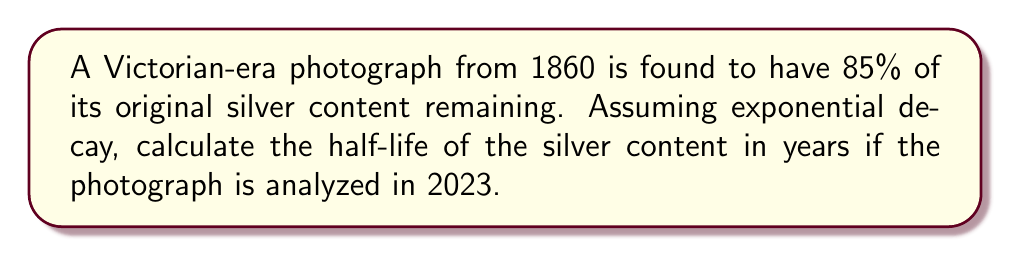Show me your answer to this math problem. Let's approach this step-by-step:

1) The exponential decay formula is:
   $$ N(t) = N_0 \cdot e^{-\lambda t} $$
   Where:
   $N(t)$ is the amount at time $t$
   $N_0$ is the initial amount
   $\lambda$ is the decay constant
   $t$ is the time elapsed

2) We know that after 163 years (2023 - 1860), 85% of the original content remains.
   So, $\frac{N(t)}{N_0} = 0.85$ and $t = 163$

3) Plugging this into our formula:
   $$ 0.85 = e^{-163\lambda} $$

4) Taking the natural log of both sides:
   $$ \ln(0.85) = -163\lambda $$

5) Solving for $\lambda$:
   $$ \lambda = -\frac{\ln(0.85)}{163} \approx 0.000998 $$

6) The half-life $t_{1/2}$ is related to $\lambda$ by:
   $$ t_{1/2} = \frac{\ln(2)}{\lambda} $$

7) Plugging in our value for $\lambda$:
   $$ t_{1/2} = \frac{\ln(2)}{0.000998} \approx 694.5 $$

Therefore, the half-life of the silver content is approximately 694.5 years.
Answer: 694.5 years 